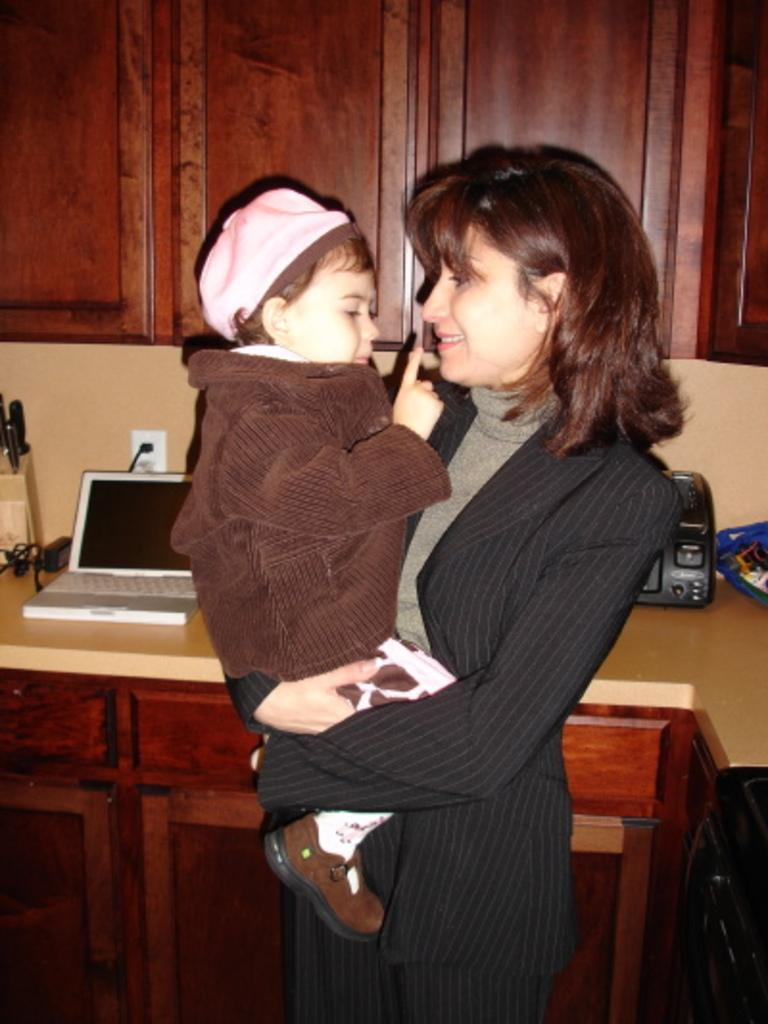What type of furniture can be seen in the background of the image? There are cupboards in the background of the image. What else is visible in the background of the image? There is a wall in the background of the image. What electronic device is on the table in the image? There is a laptop on the table in the image. What is the purpose of the socket on the table? The socket on the table is likely used for plugging in devices. What is the woman in the image holding? The woman is holding a baby in her hands. What is the woman's facial expression in the image? The woman is smiling in the image. How many balls are visible on the table in the image? There are no balls present on the table in the image. What type of bottle is visible in the image? There is no bottle present in the image. 